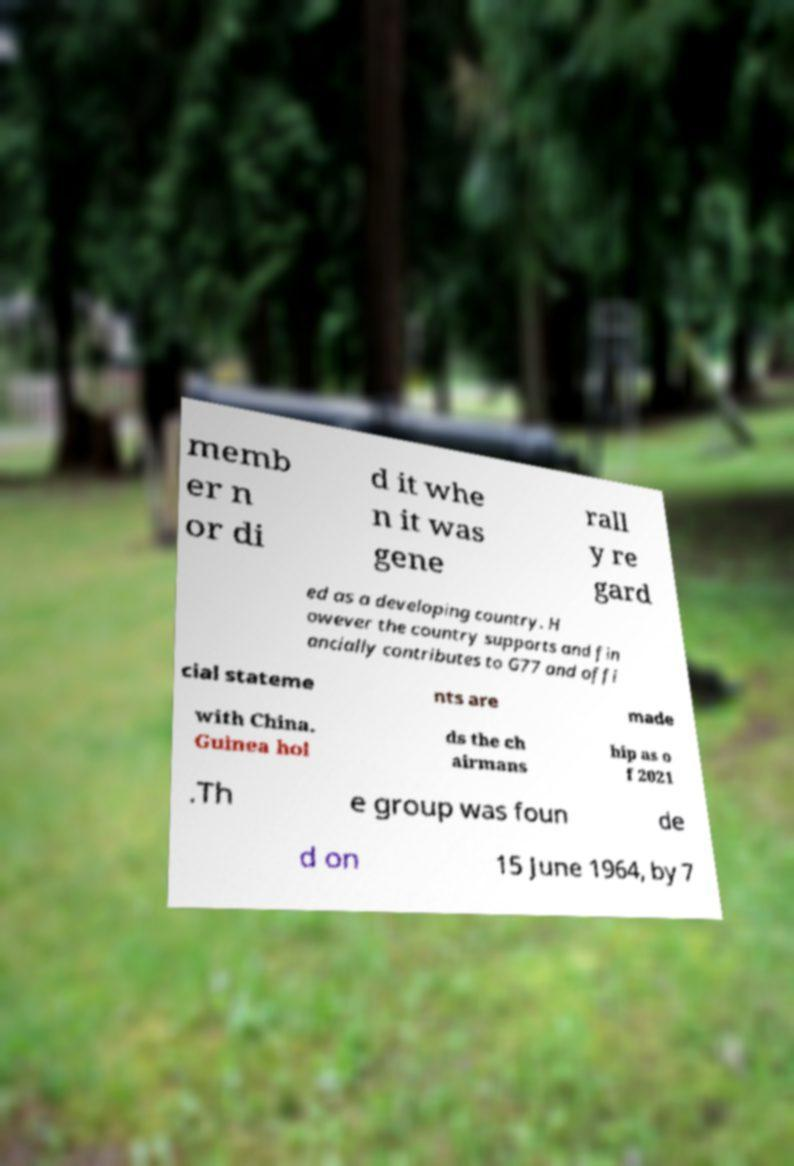Please read and relay the text visible in this image. What does it say? memb er n or di d it whe n it was gene rall y re gard ed as a developing country. H owever the country supports and fin ancially contributes to G77 and offi cial stateme nts are made with China. Guinea hol ds the ch airmans hip as o f 2021 .Th e group was foun de d on 15 June 1964, by 7 